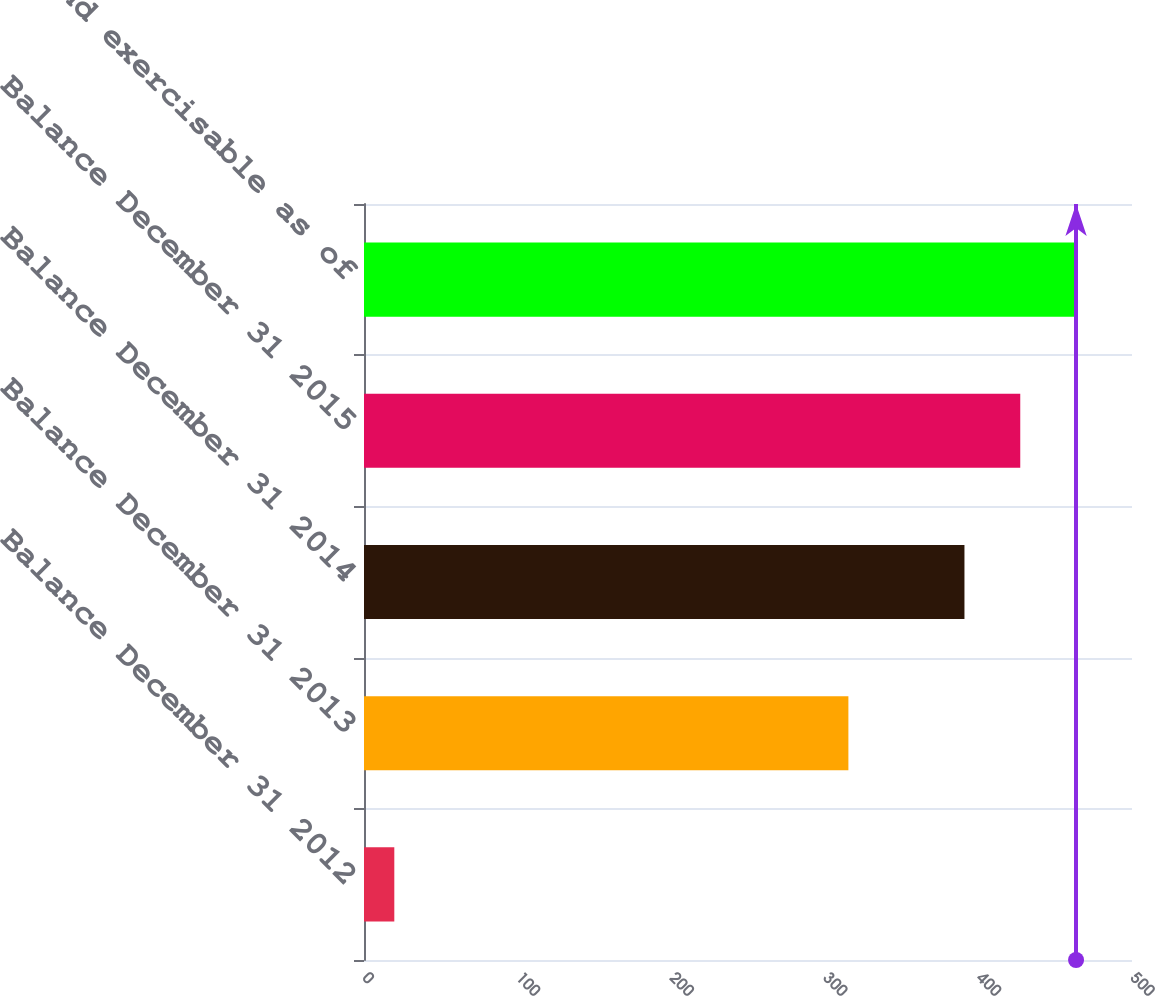<chart> <loc_0><loc_0><loc_500><loc_500><bar_chart><fcel>Balance December 31 2012<fcel>Balance December 31 2013<fcel>Balance December 31 2014<fcel>Balance December 31 2015<fcel>Vested and exercisable as of<nl><fcel>19.73<fcel>315.36<fcel>390.92<fcel>427.25<fcel>463.58<nl></chart> 